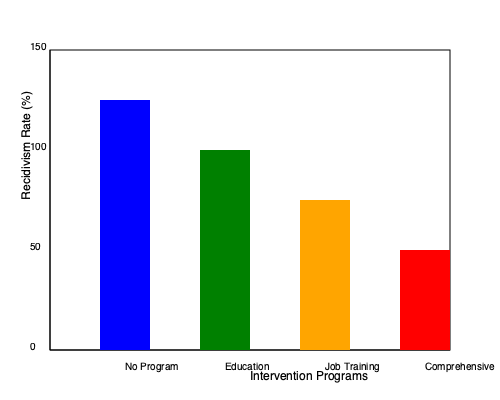Based on the bar graph showing recidivism rates for different intervention programs, what pattern can be observed, and which program appears to be most effective in reducing recidivism? To identify the pattern and determine the most effective program, we need to analyze the bar graph step by step:

1. The graph shows four different intervention programs: No Program, Education, Job Training, and Comprehensive.

2. The y-axis represents the recidivism rate as a percentage, with higher bars indicating higher recidivism rates.

3. Analyzing each program:
   - No Program (blue bar): Highest bar, indicating the highest recidivism rate.
   - Education (green bar): Second highest bar, showing a lower recidivism rate than No Program.
   - Job Training (orange bar): Third highest bar, demonstrating a further reduction in recidivism.
   - Comprehensive (red bar): Lowest bar, indicating the lowest recidivism rate.

4. The pattern observed is a consistent decrease in recidivism rates as we move from left to right across the intervention programs.

5. This pattern suggests that more comprehensive and targeted interventions lead to lower recidivism rates.

6. The Comprehensive program, represented by the rightmost red bar, shows the lowest recidivism rate, making it appear to be the most effective in reducing recidivism.
Answer: Decreasing recidivism rates with more comprehensive interventions; Comprehensive program most effective. 